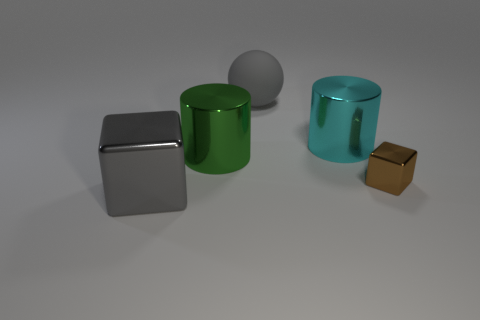How many yellow objects are big balls or small blocks?
Make the answer very short. 0. There is a metallic cube that is right of the gray sphere; is its color the same as the big shiny thing in front of the big green metal object?
Provide a short and direct response. No. There is a metal cube to the right of the big object that is right of the large gray object that is right of the large block; what is its color?
Ensure brevity in your answer.  Brown. Are there any shiny things in front of the metal cube in front of the tiny cube?
Your answer should be compact. No. Does the large gray thing in front of the matte ball have the same shape as the brown thing?
Ensure brevity in your answer.  Yes. Is there any other thing that is the same shape as the large gray rubber thing?
Keep it short and to the point. No. What number of cylinders are tiny brown things or green shiny things?
Your answer should be very brief. 1. How many cyan cylinders are there?
Offer a very short reply. 1. There is a metallic block that is on the right side of the metallic cylinder that is in front of the big cyan thing; how big is it?
Offer a very short reply. Small. What number of other objects are the same size as the brown block?
Your answer should be compact. 0. 